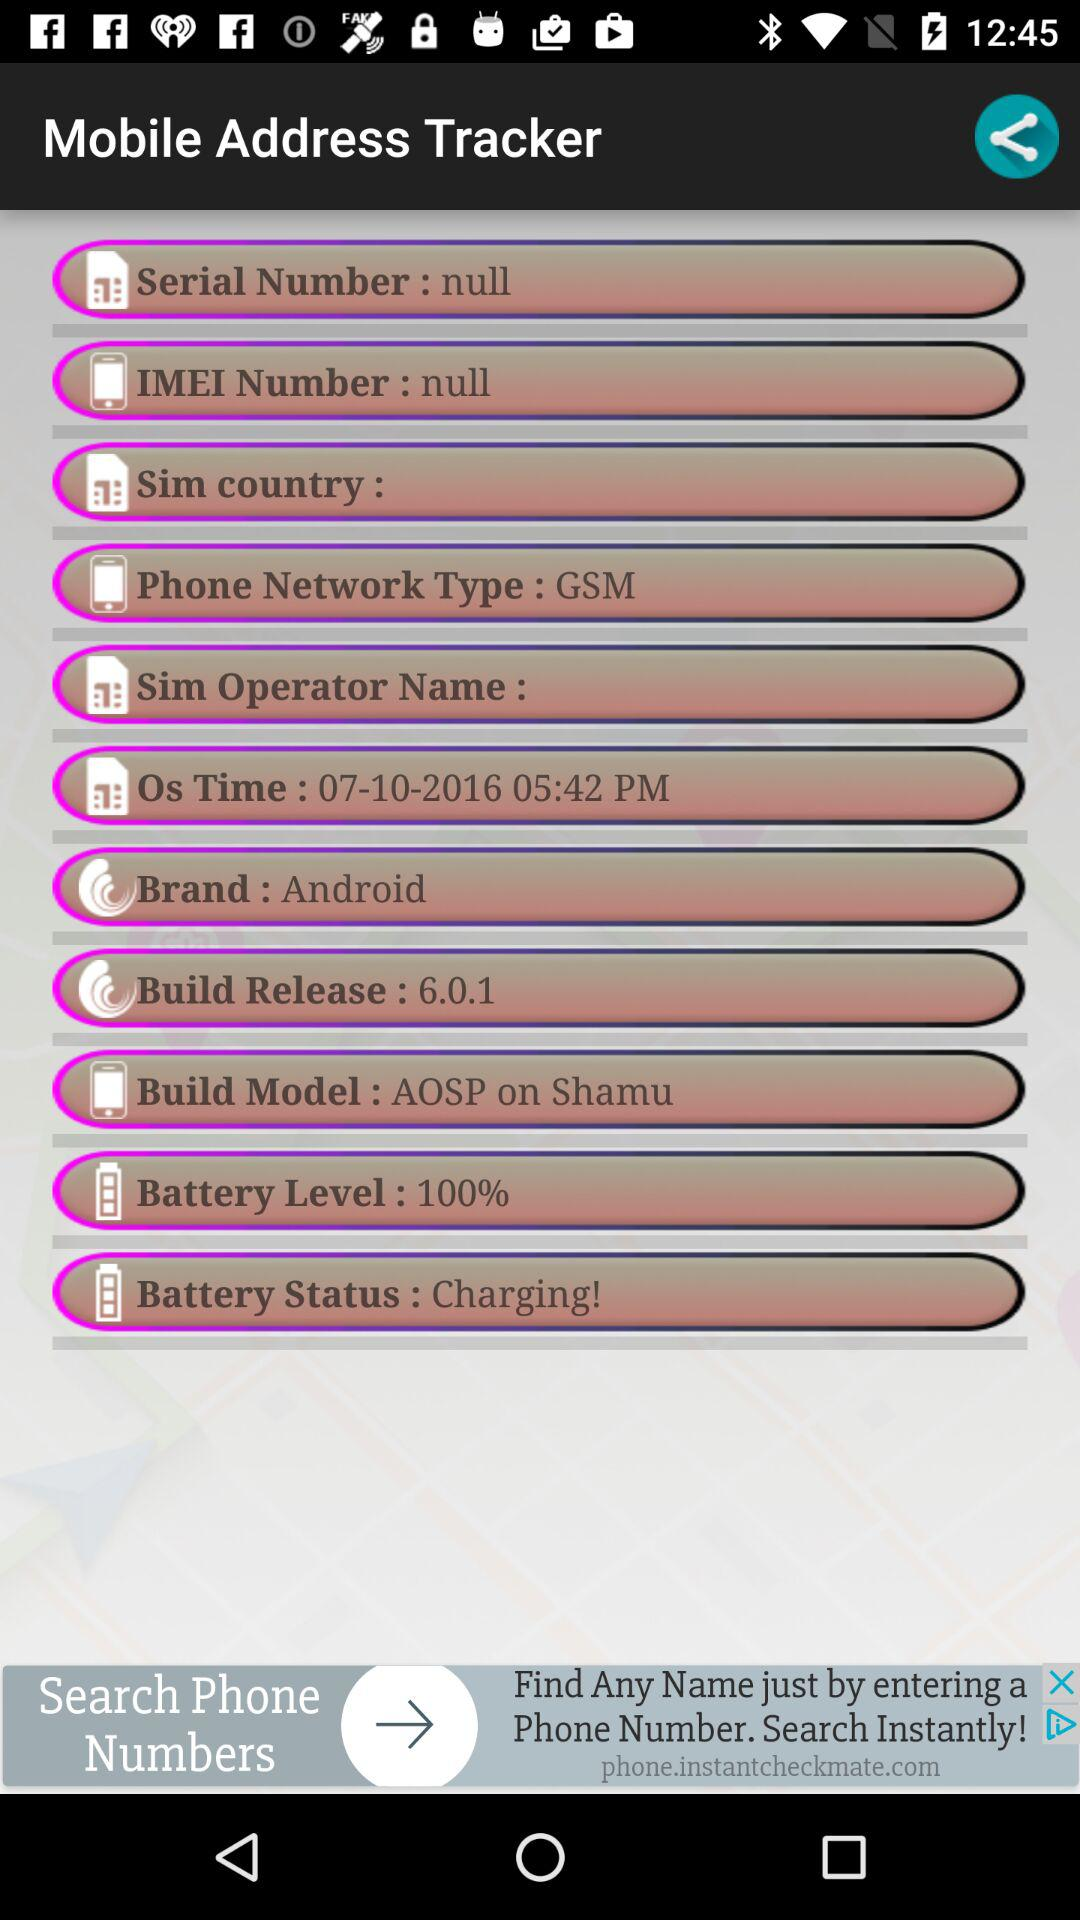What is the "Build Model" of the mobile? The "Build Model" is "AOSP on Shamu". 